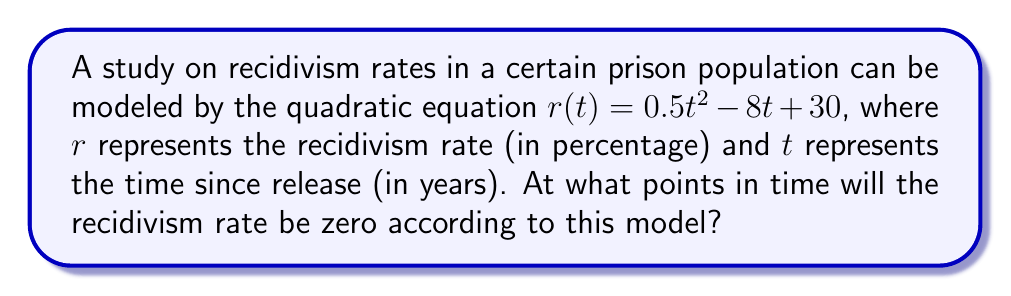Help me with this question. To find the points in time when the recidivism rate will be zero, we need to solve the equation:

$0.5t^2 - 8t + 30 = 0$

This is a quadratic equation in the standard form $ax^2 + bx + c = 0$, where:
$a = 0.5$
$b = -8$
$c = 30$

We can solve this using the quadratic formula: $x = \frac{-b \pm \sqrt{b^2 - 4ac}}{2a}$

Step 1: Calculate the discriminant $(b^2 - 4ac)$
$b^2 - 4ac = (-8)^2 - 4(0.5)(30) = 64 - 60 = 4$

Step 2: Apply the quadratic formula
$$t = \frac{-(-8) \pm \sqrt{4}}{2(0.5)} = \frac{8 \pm 2}{1} = 8 \pm 2$$

Step 3: Simplify the results
$t_1 = 8 + 2 = 10$
$t_2 = 8 - 2 = 6$

Therefore, the recidivism rate will be zero at 6 years and 10 years after release.
Answer: 6 years and 10 years 